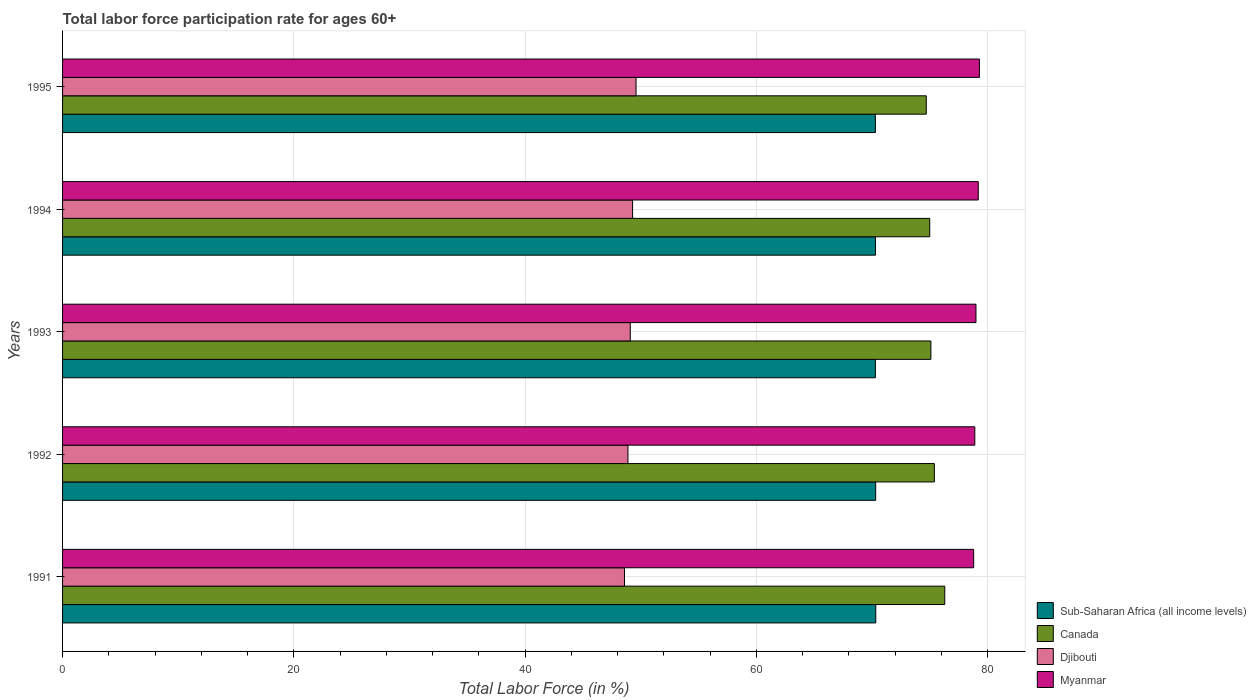How many different coloured bars are there?
Make the answer very short. 4. How many bars are there on the 3rd tick from the bottom?
Your response must be concise. 4. What is the label of the 2nd group of bars from the top?
Give a very brief answer. 1994. What is the labor force participation rate in Canada in 1991?
Give a very brief answer. 76.3. Across all years, what is the maximum labor force participation rate in Canada?
Provide a short and direct response. 76.3. Across all years, what is the minimum labor force participation rate in Djibouti?
Give a very brief answer. 48.6. In which year was the labor force participation rate in Sub-Saharan Africa (all income levels) maximum?
Provide a short and direct response. 1991. What is the total labor force participation rate in Djibouti in the graph?
Provide a short and direct response. 245.5. What is the difference between the labor force participation rate in Djibouti in 1991 and that in 1992?
Ensure brevity in your answer.  -0.3. What is the difference between the labor force participation rate in Myanmar in 1994 and the labor force participation rate in Sub-Saharan Africa (all income levels) in 1992?
Give a very brief answer. 8.88. What is the average labor force participation rate in Djibouti per year?
Provide a succinct answer. 49.1. In the year 1991, what is the difference between the labor force participation rate in Myanmar and labor force participation rate in Djibouti?
Provide a succinct answer. 30.2. What is the ratio of the labor force participation rate in Sub-Saharan Africa (all income levels) in 1991 to that in 1995?
Offer a terse response. 1. Is the difference between the labor force participation rate in Myanmar in 1991 and 1993 greater than the difference between the labor force participation rate in Djibouti in 1991 and 1993?
Provide a succinct answer. Yes. What is the difference between the highest and the second highest labor force participation rate in Canada?
Give a very brief answer. 0.9. Is the sum of the labor force participation rate in Myanmar in 1993 and 1994 greater than the maximum labor force participation rate in Canada across all years?
Make the answer very short. Yes. Is it the case that in every year, the sum of the labor force participation rate in Myanmar and labor force participation rate in Canada is greater than the sum of labor force participation rate in Sub-Saharan Africa (all income levels) and labor force participation rate in Djibouti?
Offer a very short reply. Yes. What does the 3rd bar from the top in 1994 represents?
Offer a very short reply. Canada. What does the 3rd bar from the bottom in 1991 represents?
Provide a short and direct response. Djibouti. Is it the case that in every year, the sum of the labor force participation rate in Djibouti and labor force participation rate in Myanmar is greater than the labor force participation rate in Canada?
Give a very brief answer. Yes. Are all the bars in the graph horizontal?
Provide a succinct answer. Yes. Does the graph contain any zero values?
Provide a short and direct response. No. How many legend labels are there?
Ensure brevity in your answer.  4. How are the legend labels stacked?
Your answer should be very brief. Vertical. What is the title of the graph?
Provide a short and direct response. Total labor force participation rate for ages 60+. What is the Total Labor Force (in %) in Sub-Saharan Africa (all income levels) in 1991?
Make the answer very short. 70.33. What is the Total Labor Force (in %) in Canada in 1991?
Keep it short and to the point. 76.3. What is the Total Labor Force (in %) in Djibouti in 1991?
Provide a succinct answer. 48.6. What is the Total Labor Force (in %) of Myanmar in 1991?
Ensure brevity in your answer.  78.8. What is the Total Labor Force (in %) of Sub-Saharan Africa (all income levels) in 1992?
Provide a succinct answer. 70.32. What is the Total Labor Force (in %) of Canada in 1992?
Provide a short and direct response. 75.4. What is the Total Labor Force (in %) in Djibouti in 1992?
Your response must be concise. 48.9. What is the Total Labor Force (in %) of Myanmar in 1992?
Your response must be concise. 78.9. What is the Total Labor Force (in %) in Sub-Saharan Africa (all income levels) in 1993?
Your answer should be compact. 70.3. What is the Total Labor Force (in %) in Canada in 1993?
Offer a terse response. 75.1. What is the Total Labor Force (in %) of Djibouti in 1993?
Your answer should be compact. 49.1. What is the Total Labor Force (in %) in Myanmar in 1993?
Offer a terse response. 79. What is the Total Labor Force (in %) in Sub-Saharan Africa (all income levels) in 1994?
Offer a very short reply. 70.31. What is the Total Labor Force (in %) of Djibouti in 1994?
Ensure brevity in your answer.  49.3. What is the Total Labor Force (in %) of Myanmar in 1994?
Offer a very short reply. 79.2. What is the Total Labor Force (in %) of Sub-Saharan Africa (all income levels) in 1995?
Offer a terse response. 70.3. What is the Total Labor Force (in %) in Canada in 1995?
Provide a short and direct response. 74.7. What is the Total Labor Force (in %) of Djibouti in 1995?
Offer a very short reply. 49.6. What is the Total Labor Force (in %) of Myanmar in 1995?
Your answer should be compact. 79.3. Across all years, what is the maximum Total Labor Force (in %) in Sub-Saharan Africa (all income levels)?
Give a very brief answer. 70.33. Across all years, what is the maximum Total Labor Force (in %) of Canada?
Your response must be concise. 76.3. Across all years, what is the maximum Total Labor Force (in %) of Djibouti?
Your answer should be compact. 49.6. Across all years, what is the maximum Total Labor Force (in %) in Myanmar?
Your answer should be compact. 79.3. Across all years, what is the minimum Total Labor Force (in %) in Sub-Saharan Africa (all income levels)?
Offer a terse response. 70.3. Across all years, what is the minimum Total Labor Force (in %) in Canada?
Provide a succinct answer. 74.7. Across all years, what is the minimum Total Labor Force (in %) of Djibouti?
Your answer should be very brief. 48.6. Across all years, what is the minimum Total Labor Force (in %) of Myanmar?
Your answer should be compact. 78.8. What is the total Total Labor Force (in %) in Sub-Saharan Africa (all income levels) in the graph?
Offer a terse response. 351.57. What is the total Total Labor Force (in %) of Canada in the graph?
Offer a very short reply. 376.5. What is the total Total Labor Force (in %) in Djibouti in the graph?
Provide a short and direct response. 245.5. What is the total Total Labor Force (in %) of Myanmar in the graph?
Ensure brevity in your answer.  395.2. What is the difference between the Total Labor Force (in %) of Sub-Saharan Africa (all income levels) in 1991 and that in 1992?
Offer a terse response. 0.01. What is the difference between the Total Labor Force (in %) of Sub-Saharan Africa (all income levels) in 1991 and that in 1993?
Keep it short and to the point. 0.03. What is the difference between the Total Labor Force (in %) of Canada in 1991 and that in 1993?
Provide a short and direct response. 1.2. What is the difference between the Total Labor Force (in %) of Sub-Saharan Africa (all income levels) in 1991 and that in 1994?
Ensure brevity in your answer.  0.02. What is the difference between the Total Labor Force (in %) in Canada in 1991 and that in 1994?
Make the answer very short. 1.3. What is the difference between the Total Labor Force (in %) in Sub-Saharan Africa (all income levels) in 1991 and that in 1995?
Your answer should be very brief. 0.03. What is the difference between the Total Labor Force (in %) in Canada in 1991 and that in 1995?
Your response must be concise. 1.6. What is the difference between the Total Labor Force (in %) of Djibouti in 1991 and that in 1995?
Your answer should be very brief. -1. What is the difference between the Total Labor Force (in %) in Sub-Saharan Africa (all income levels) in 1992 and that in 1993?
Keep it short and to the point. 0.03. What is the difference between the Total Labor Force (in %) of Sub-Saharan Africa (all income levels) in 1992 and that in 1994?
Your answer should be compact. 0.01. What is the difference between the Total Labor Force (in %) of Canada in 1992 and that in 1994?
Your answer should be compact. 0.4. What is the difference between the Total Labor Force (in %) in Sub-Saharan Africa (all income levels) in 1992 and that in 1995?
Offer a very short reply. 0.02. What is the difference between the Total Labor Force (in %) of Djibouti in 1992 and that in 1995?
Make the answer very short. -0.7. What is the difference between the Total Labor Force (in %) of Sub-Saharan Africa (all income levels) in 1993 and that in 1994?
Your answer should be very brief. -0.01. What is the difference between the Total Labor Force (in %) of Canada in 1993 and that in 1994?
Your answer should be compact. 0.1. What is the difference between the Total Labor Force (in %) of Sub-Saharan Africa (all income levels) in 1993 and that in 1995?
Your answer should be compact. -0. What is the difference between the Total Labor Force (in %) in Djibouti in 1993 and that in 1995?
Your response must be concise. -0.5. What is the difference between the Total Labor Force (in %) in Myanmar in 1993 and that in 1995?
Your answer should be compact. -0.3. What is the difference between the Total Labor Force (in %) in Sub-Saharan Africa (all income levels) in 1994 and that in 1995?
Offer a very short reply. 0.01. What is the difference between the Total Labor Force (in %) in Canada in 1994 and that in 1995?
Ensure brevity in your answer.  0.3. What is the difference between the Total Labor Force (in %) in Djibouti in 1994 and that in 1995?
Your answer should be compact. -0.3. What is the difference between the Total Labor Force (in %) in Myanmar in 1994 and that in 1995?
Make the answer very short. -0.1. What is the difference between the Total Labor Force (in %) of Sub-Saharan Africa (all income levels) in 1991 and the Total Labor Force (in %) of Canada in 1992?
Offer a very short reply. -5.07. What is the difference between the Total Labor Force (in %) in Sub-Saharan Africa (all income levels) in 1991 and the Total Labor Force (in %) in Djibouti in 1992?
Offer a terse response. 21.43. What is the difference between the Total Labor Force (in %) in Sub-Saharan Africa (all income levels) in 1991 and the Total Labor Force (in %) in Myanmar in 1992?
Your answer should be compact. -8.57. What is the difference between the Total Labor Force (in %) in Canada in 1991 and the Total Labor Force (in %) in Djibouti in 1992?
Provide a succinct answer. 27.4. What is the difference between the Total Labor Force (in %) of Canada in 1991 and the Total Labor Force (in %) of Myanmar in 1992?
Offer a terse response. -2.6. What is the difference between the Total Labor Force (in %) of Djibouti in 1991 and the Total Labor Force (in %) of Myanmar in 1992?
Provide a succinct answer. -30.3. What is the difference between the Total Labor Force (in %) of Sub-Saharan Africa (all income levels) in 1991 and the Total Labor Force (in %) of Canada in 1993?
Give a very brief answer. -4.77. What is the difference between the Total Labor Force (in %) in Sub-Saharan Africa (all income levels) in 1991 and the Total Labor Force (in %) in Djibouti in 1993?
Keep it short and to the point. 21.23. What is the difference between the Total Labor Force (in %) in Sub-Saharan Africa (all income levels) in 1991 and the Total Labor Force (in %) in Myanmar in 1993?
Provide a short and direct response. -8.67. What is the difference between the Total Labor Force (in %) of Canada in 1991 and the Total Labor Force (in %) of Djibouti in 1993?
Provide a short and direct response. 27.2. What is the difference between the Total Labor Force (in %) in Djibouti in 1991 and the Total Labor Force (in %) in Myanmar in 1993?
Offer a terse response. -30.4. What is the difference between the Total Labor Force (in %) in Sub-Saharan Africa (all income levels) in 1991 and the Total Labor Force (in %) in Canada in 1994?
Keep it short and to the point. -4.67. What is the difference between the Total Labor Force (in %) in Sub-Saharan Africa (all income levels) in 1991 and the Total Labor Force (in %) in Djibouti in 1994?
Provide a short and direct response. 21.03. What is the difference between the Total Labor Force (in %) in Sub-Saharan Africa (all income levels) in 1991 and the Total Labor Force (in %) in Myanmar in 1994?
Ensure brevity in your answer.  -8.87. What is the difference between the Total Labor Force (in %) in Canada in 1991 and the Total Labor Force (in %) in Djibouti in 1994?
Make the answer very short. 27. What is the difference between the Total Labor Force (in %) in Djibouti in 1991 and the Total Labor Force (in %) in Myanmar in 1994?
Make the answer very short. -30.6. What is the difference between the Total Labor Force (in %) of Sub-Saharan Africa (all income levels) in 1991 and the Total Labor Force (in %) of Canada in 1995?
Give a very brief answer. -4.37. What is the difference between the Total Labor Force (in %) in Sub-Saharan Africa (all income levels) in 1991 and the Total Labor Force (in %) in Djibouti in 1995?
Provide a succinct answer. 20.73. What is the difference between the Total Labor Force (in %) in Sub-Saharan Africa (all income levels) in 1991 and the Total Labor Force (in %) in Myanmar in 1995?
Your answer should be compact. -8.97. What is the difference between the Total Labor Force (in %) of Canada in 1991 and the Total Labor Force (in %) of Djibouti in 1995?
Make the answer very short. 26.7. What is the difference between the Total Labor Force (in %) of Djibouti in 1991 and the Total Labor Force (in %) of Myanmar in 1995?
Your response must be concise. -30.7. What is the difference between the Total Labor Force (in %) in Sub-Saharan Africa (all income levels) in 1992 and the Total Labor Force (in %) in Canada in 1993?
Your answer should be compact. -4.78. What is the difference between the Total Labor Force (in %) in Sub-Saharan Africa (all income levels) in 1992 and the Total Labor Force (in %) in Djibouti in 1993?
Provide a succinct answer. 21.22. What is the difference between the Total Labor Force (in %) of Sub-Saharan Africa (all income levels) in 1992 and the Total Labor Force (in %) of Myanmar in 1993?
Provide a short and direct response. -8.68. What is the difference between the Total Labor Force (in %) of Canada in 1992 and the Total Labor Force (in %) of Djibouti in 1993?
Give a very brief answer. 26.3. What is the difference between the Total Labor Force (in %) of Djibouti in 1992 and the Total Labor Force (in %) of Myanmar in 1993?
Make the answer very short. -30.1. What is the difference between the Total Labor Force (in %) in Sub-Saharan Africa (all income levels) in 1992 and the Total Labor Force (in %) in Canada in 1994?
Offer a very short reply. -4.68. What is the difference between the Total Labor Force (in %) of Sub-Saharan Africa (all income levels) in 1992 and the Total Labor Force (in %) of Djibouti in 1994?
Make the answer very short. 21.02. What is the difference between the Total Labor Force (in %) in Sub-Saharan Africa (all income levels) in 1992 and the Total Labor Force (in %) in Myanmar in 1994?
Your answer should be very brief. -8.88. What is the difference between the Total Labor Force (in %) of Canada in 1992 and the Total Labor Force (in %) of Djibouti in 1994?
Make the answer very short. 26.1. What is the difference between the Total Labor Force (in %) in Djibouti in 1992 and the Total Labor Force (in %) in Myanmar in 1994?
Give a very brief answer. -30.3. What is the difference between the Total Labor Force (in %) in Sub-Saharan Africa (all income levels) in 1992 and the Total Labor Force (in %) in Canada in 1995?
Keep it short and to the point. -4.38. What is the difference between the Total Labor Force (in %) of Sub-Saharan Africa (all income levels) in 1992 and the Total Labor Force (in %) of Djibouti in 1995?
Ensure brevity in your answer.  20.72. What is the difference between the Total Labor Force (in %) of Sub-Saharan Africa (all income levels) in 1992 and the Total Labor Force (in %) of Myanmar in 1995?
Provide a succinct answer. -8.98. What is the difference between the Total Labor Force (in %) in Canada in 1992 and the Total Labor Force (in %) in Djibouti in 1995?
Your answer should be very brief. 25.8. What is the difference between the Total Labor Force (in %) of Canada in 1992 and the Total Labor Force (in %) of Myanmar in 1995?
Ensure brevity in your answer.  -3.9. What is the difference between the Total Labor Force (in %) of Djibouti in 1992 and the Total Labor Force (in %) of Myanmar in 1995?
Keep it short and to the point. -30.4. What is the difference between the Total Labor Force (in %) of Sub-Saharan Africa (all income levels) in 1993 and the Total Labor Force (in %) of Canada in 1994?
Your answer should be compact. -4.7. What is the difference between the Total Labor Force (in %) of Sub-Saharan Africa (all income levels) in 1993 and the Total Labor Force (in %) of Djibouti in 1994?
Offer a terse response. 21. What is the difference between the Total Labor Force (in %) in Sub-Saharan Africa (all income levels) in 1993 and the Total Labor Force (in %) in Myanmar in 1994?
Offer a very short reply. -8.9. What is the difference between the Total Labor Force (in %) in Canada in 1993 and the Total Labor Force (in %) in Djibouti in 1994?
Keep it short and to the point. 25.8. What is the difference between the Total Labor Force (in %) in Canada in 1993 and the Total Labor Force (in %) in Myanmar in 1994?
Your response must be concise. -4.1. What is the difference between the Total Labor Force (in %) of Djibouti in 1993 and the Total Labor Force (in %) of Myanmar in 1994?
Your answer should be compact. -30.1. What is the difference between the Total Labor Force (in %) in Sub-Saharan Africa (all income levels) in 1993 and the Total Labor Force (in %) in Canada in 1995?
Provide a succinct answer. -4.4. What is the difference between the Total Labor Force (in %) of Sub-Saharan Africa (all income levels) in 1993 and the Total Labor Force (in %) of Djibouti in 1995?
Make the answer very short. 20.7. What is the difference between the Total Labor Force (in %) in Sub-Saharan Africa (all income levels) in 1993 and the Total Labor Force (in %) in Myanmar in 1995?
Your answer should be very brief. -9. What is the difference between the Total Labor Force (in %) of Canada in 1993 and the Total Labor Force (in %) of Djibouti in 1995?
Your answer should be very brief. 25.5. What is the difference between the Total Labor Force (in %) in Djibouti in 1993 and the Total Labor Force (in %) in Myanmar in 1995?
Provide a succinct answer. -30.2. What is the difference between the Total Labor Force (in %) in Sub-Saharan Africa (all income levels) in 1994 and the Total Labor Force (in %) in Canada in 1995?
Offer a very short reply. -4.39. What is the difference between the Total Labor Force (in %) in Sub-Saharan Africa (all income levels) in 1994 and the Total Labor Force (in %) in Djibouti in 1995?
Make the answer very short. 20.71. What is the difference between the Total Labor Force (in %) of Sub-Saharan Africa (all income levels) in 1994 and the Total Labor Force (in %) of Myanmar in 1995?
Make the answer very short. -8.99. What is the difference between the Total Labor Force (in %) of Canada in 1994 and the Total Labor Force (in %) of Djibouti in 1995?
Your response must be concise. 25.4. What is the difference between the Total Labor Force (in %) of Djibouti in 1994 and the Total Labor Force (in %) of Myanmar in 1995?
Your answer should be very brief. -30. What is the average Total Labor Force (in %) of Sub-Saharan Africa (all income levels) per year?
Offer a very short reply. 70.31. What is the average Total Labor Force (in %) in Canada per year?
Ensure brevity in your answer.  75.3. What is the average Total Labor Force (in %) of Djibouti per year?
Your answer should be compact. 49.1. What is the average Total Labor Force (in %) in Myanmar per year?
Your answer should be very brief. 79.04. In the year 1991, what is the difference between the Total Labor Force (in %) of Sub-Saharan Africa (all income levels) and Total Labor Force (in %) of Canada?
Ensure brevity in your answer.  -5.97. In the year 1991, what is the difference between the Total Labor Force (in %) in Sub-Saharan Africa (all income levels) and Total Labor Force (in %) in Djibouti?
Provide a succinct answer. 21.73. In the year 1991, what is the difference between the Total Labor Force (in %) of Sub-Saharan Africa (all income levels) and Total Labor Force (in %) of Myanmar?
Provide a short and direct response. -8.47. In the year 1991, what is the difference between the Total Labor Force (in %) of Canada and Total Labor Force (in %) of Djibouti?
Make the answer very short. 27.7. In the year 1991, what is the difference between the Total Labor Force (in %) of Canada and Total Labor Force (in %) of Myanmar?
Provide a short and direct response. -2.5. In the year 1991, what is the difference between the Total Labor Force (in %) in Djibouti and Total Labor Force (in %) in Myanmar?
Offer a terse response. -30.2. In the year 1992, what is the difference between the Total Labor Force (in %) of Sub-Saharan Africa (all income levels) and Total Labor Force (in %) of Canada?
Ensure brevity in your answer.  -5.08. In the year 1992, what is the difference between the Total Labor Force (in %) in Sub-Saharan Africa (all income levels) and Total Labor Force (in %) in Djibouti?
Offer a very short reply. 21.42. In the year 1992, what is the difference between the Total Labor Force (in %) in Sub-Saharan Africa (all income levels) and Total Labor Force (in %) in Myanmar?
Your answer should be compact. -8.58. In the year 1992, what is the difference between the Total Labor Force (in %) of Canada and Total Labor Force (in %) of Djibouti?
Provide a succinct answer. 26.5. In the year 1993, what is the difference between the Total Labor Force (in %) in Sub-Saharan Africa (all income levels) and Total Labor Force (in %) in Canada?
Your response must be concise. -4.8. In the year 1993, what is the difference between the Total Labor Force (in %) in Sub-Saharan Africa (all income levels) and Total Labor Force (in %) in Djibouti?
Your response must be concise. 21.2. In the year 1993, what is the difference between the Total Labor Force (in %) in Sub-Saharan Africa (all income levels) and Total Labor Force (in %) in Myanmar?
Offer a very short reply. -8.7. In the year 1993, what is the difference between the Total Labor Force (in %) in Canada and Total Labor Force (in %) in Myanmar?
Keep it short and to the point. -3.9. In the year 1993, what is the difference between the Total Labor Force (in %) of Djibouti and Total Labor Force (in %) of Myanmar?
Provide a succinct answer. -29.9. In the year 1994, what is the difference between the Total Labor Force (in %) in Sub-Saharan Africa (all income levels) and Total Labor Force (in %) in Canada?
Your response must be concise. -4.69. In the year 1994, what is the difference between the Total Labor Force (in %) of Sub-Saharan Africa (all income levels) and Total Labor Force (in %) of Djibouti?
Your response must be concise. 21.01. In the year 1994, what is the difference between the Total Labor Force (in %) of Sub-Saharan Africa (all income levels) and Total Labor Force (in %) of Myanmar?
Keep it short and to the point. -8.89. In the year 1994, what is the difference between the Total Labor Force (in %) in Canada and Total Labor Force (in %) in Djibouti?
Offer a very short reply. 25.7. In the year 1994, what is the difference between the Total Labor Force (in %) of Djibouti and Total Labor Force (in %) of Myanmar?
Your answer should be very brief. -29.9. In the year 1995, what is the difference between the Total Labor Force (in %) in Sub-Saharan Africa (all income levels) and Total Labor Force (in %) in Canada?
Keep it short and to the point. -4.4. In the year 1995, what is the difference between the Total Labor Force (in %) of Sub-Saharan Africa (all income levels) and Total Labor Force (in %) of Djibouti?
Offer a terse response. 20.7. In the year 1995, what is the difference between the Total Labor Force (in %) in Sub-Saharan Africa (all income levels) and Total Labor Force (in %) in Myanmar?
Your answer should be very brief. -9. In the year 1995, what is the difference between the Total Labor Force (in %) of Canada and Total Labor Force (in %) of Djibouti?
Keep it short and to the point. 25.1. In the year 1995, what is the difference between the Total Labor Force (in %) of Djibouti and Total Labor Force (in %) of Myanmar?
Your response must be concise. -29.7. What is the ratio of the Total Labor Force (in %) in Canada in 1991 to that in 1992?
Make the answer very short. 1.01. What is the ratio of the Total Labor Force (in %) in Myanmar in 1991 to that in 1992?
Give a very brief answer. 1. What is the ratio of the Total Labor Force (in %) in Sub-Saharan Africa (all income levels) in 1991 to that in 1993?
Your answer should be compact. 1. What is the ratio of the Total Labor Force (in %) in Canada in 1991 to that in 1993?
Your response must be concise. 1.02. What is the ratio of the Total Labor Force (in %) in Djibouti in 1991 to that in 1993?
Offer a very short reply. 0.99. What is the ratio of the Total Labor Force (in %) of Sub-Saharan Africa (all income levels) in 1991 to that in 1994?
Provide a succinct answer. 1. What is the ratio of the Total Labor Force (in %) of Canada in 1991 to that in 1994?
Provide a succinct answer. 1.02. What is the ratio of the Total Labor Force (in %) in Djibouti in 1991 to that in 1994?
Provide a succinct answer. 0.99. What is the ratio of the Total Labor Force (in %) of Myanmar in 1991 to that in 1994?
Your answer should be compact. 0.99. What is the ratio of the Total Labor Force (in %) of Canada in 1991 to that in 1995?
Make the answer very short. 1.02. What is the ratio of the Total Labor Force (in %) of Djibouti in 1991 to that in 1995?
Ensure brevity in your answer.  0.98. What is the ratio of the Total Labor Force (in %) in Myanmar in 1991 to that in 1995?
Your answer should be very brief. 0.99. What is the ratio of the Total Labor Force (in %) of Canada in 1992 to that in 1993?
Keep it short and to the point. 1. What is the ratio of the Total Labor Force (in %) in Sub-Saharan Africa (all income levels) in 1992 to that in 1994?
Make the answer very short. 1. What is the ratio of the Total Labor Force (in %) of Canada in 1992 to that in 1995?
Your answer should be very brief. 1.01. What is the ratio of the Total Labor Force (in %) in Djibouti in 1992 to that in 1995?
Make the answer very short. 0.99. What is the ratio of the Total Labor Force (in %) of Myanmar in 1992 to that in 1995?
Ensure brevity in your answer.  0.99. What is the ratio of the Total Labor Force (in %) of Sub-Saharan Africa (all income levels) in 1993 to that in 1994?
Keep it short and to the point. 1. What is the ratio of the Total Labor Force (in %) in Canada in 1993 to that in 1994?
Keep it short and to the point. 1. What is the ratio of the Total Labor Force (in %) of Myanmar in 1993 to that in 1994?
Give a very brief answer. 1. What is the ratio of the Total Labor Force (in %) of Sub-Saharan Africa (all income levels) in 1993 to that in 1995?
Keep it short and to the point. 1. What is the ratio of the Total Labor Force (in %) in Canada in 1993 to that in 1995?
Offer a terse response. 1.01. What is the ratio of the Total Labor Force (in %) of Djibouti in 1993 to that in 1995?
Make the answer very short. 0.99. What is the ratio of the Total Labor Force (in %) in Canada in 1994 to that in 1995?
Give a very brief answer. 1. What is the ratio of the Total Labor Force (in %) in Djibouti in 1994 to that in 1995?
Your response must be concise. 0.99. What is the ratio of the Total Labor Force (in %) of Myanmar in 1994 to that in 1995?
Make the answer very short. 1. What is the difference between the highest and the second highest Total Labor Force (in %) of Sub-Saharan Africa (all income levels)?
Provide a succinct answer. 0.01. What is the difference between the highest and the second highest Total Labor Force (in %) of Djibouti?
Ensure brevity in your answer.  0.3. What is the difference between the highest and the second highest Total Labor Force (in %) of Myanmar?
Your answer should be compact. 0.1. What is the difference between the highest and the lowest Total Labor Force (in %) in Sub-Saharan Africa (all income levels)?
Your answer should be very brief. 0.03. What is the difference between the highest and the lowest Total Labor Force (in %) in Canada?
Offer a terse response. 1.6. What is the difference between the highest and the lowest Total Labor Force (in %) in Myanmar?
Your answer should be very brief. 0.5. 